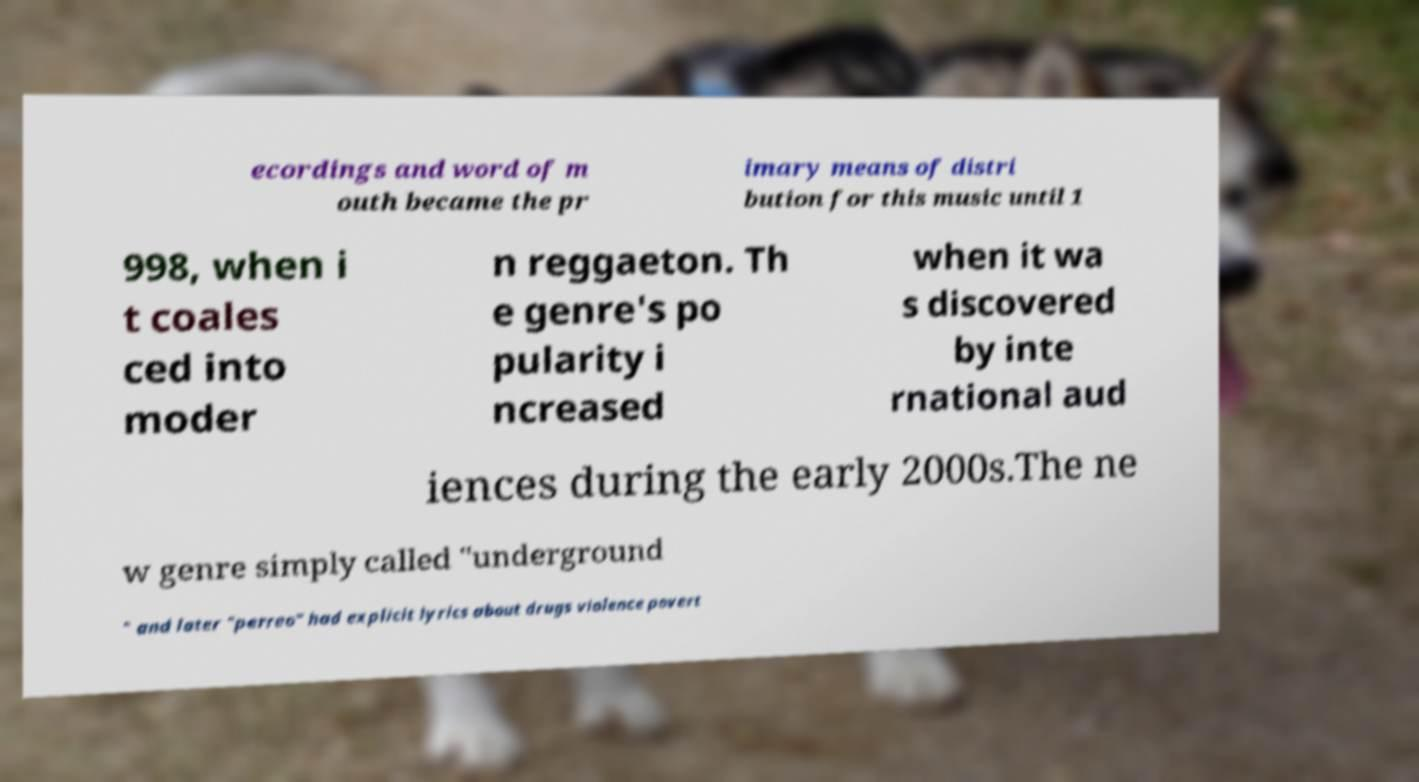Can you read and provide the text displayed in the image?This photo seems to have some interesting text. Can you extract and type it out for me? ecordings and word of m outh became the pr imary means of distri bution for this music until 1 998, when i t coales ced into moder n reggaeton. Th e genre's po pularity i ncreased when it wa s discovered by inte rnational aud iences during the early 2000s.The ne w genre simply called "underground " and later "perreo" had explicit lyrics about drugs violence povert 